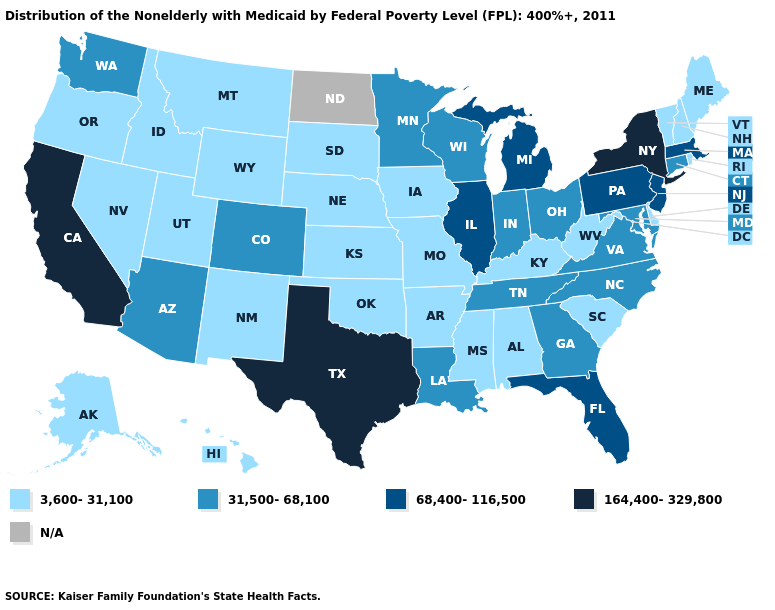Among the states that border Vermont , which have the lowest value?
Short answer required. New Hampshire. Which states have the highest value in the USA?
Give a very brief answer. California, New York, Texas. Name the states that have a value in the range 68,400-116,500?
Write a very short answer. Florida, Illinois, Massachusetts, Michigan, New Jersey, Pennsylvania. What is the value of Kentucky?
Give a very brief answer. 3,600-31,100. What is the lowest value in the West?
Give a very brief answer. 3,600-31,100. Which states have the lowest value in the USA?
Give a very brief answer. Alabama, Alaska, Arkansas, Delaware, Hawaii, Idaho, Iowa, Kansas, Kentucky, Maine, Mississippi, Missouri, Montana, Nebraska, Nevada, New Hampshire, New Mexico, Oklahoma, Oregon, Rhode Island, South Carolina, South Dakota, Utah, Vermont, West Virginia, Wyoming. Name the states that have a value in the range 164,400-329,800?
Be succinct. California, New York, Texas. What is the lowest value in the MidWest?
Short answer required. 3,600-31,100. Name the states that have a value in the range 31,500-68,100?
Short answer required. Arizona, Colorado, Connecticut, Georgia, Indiana, Louisiana, Maryland, Minnesota, North Carolina, Ohio, Tennessee, Virginia, Washington, Wisconsin. Which states have the lowest value in the Northeast?
Answer briefly. Maine, New Hampshire, Rhode Island, Vermont. What is the value of North Dakota?
Short answer required. N/A. Name the states that have a value in the range 164,400-329,800?
Write a very short answer. California, New York, Texas. What is the highest value in the MidWest ?
Answer briefly. 68,400-116,500. What is the highest value in the USA?
Give a very brief answer. 164,400-329,800. Which states have the lowest value in the South?
Answer briefly. Alabama, Arkansas, Delaware, Kentucky, Mississippi, Oklahoma, South Carolina, West Virginia. 